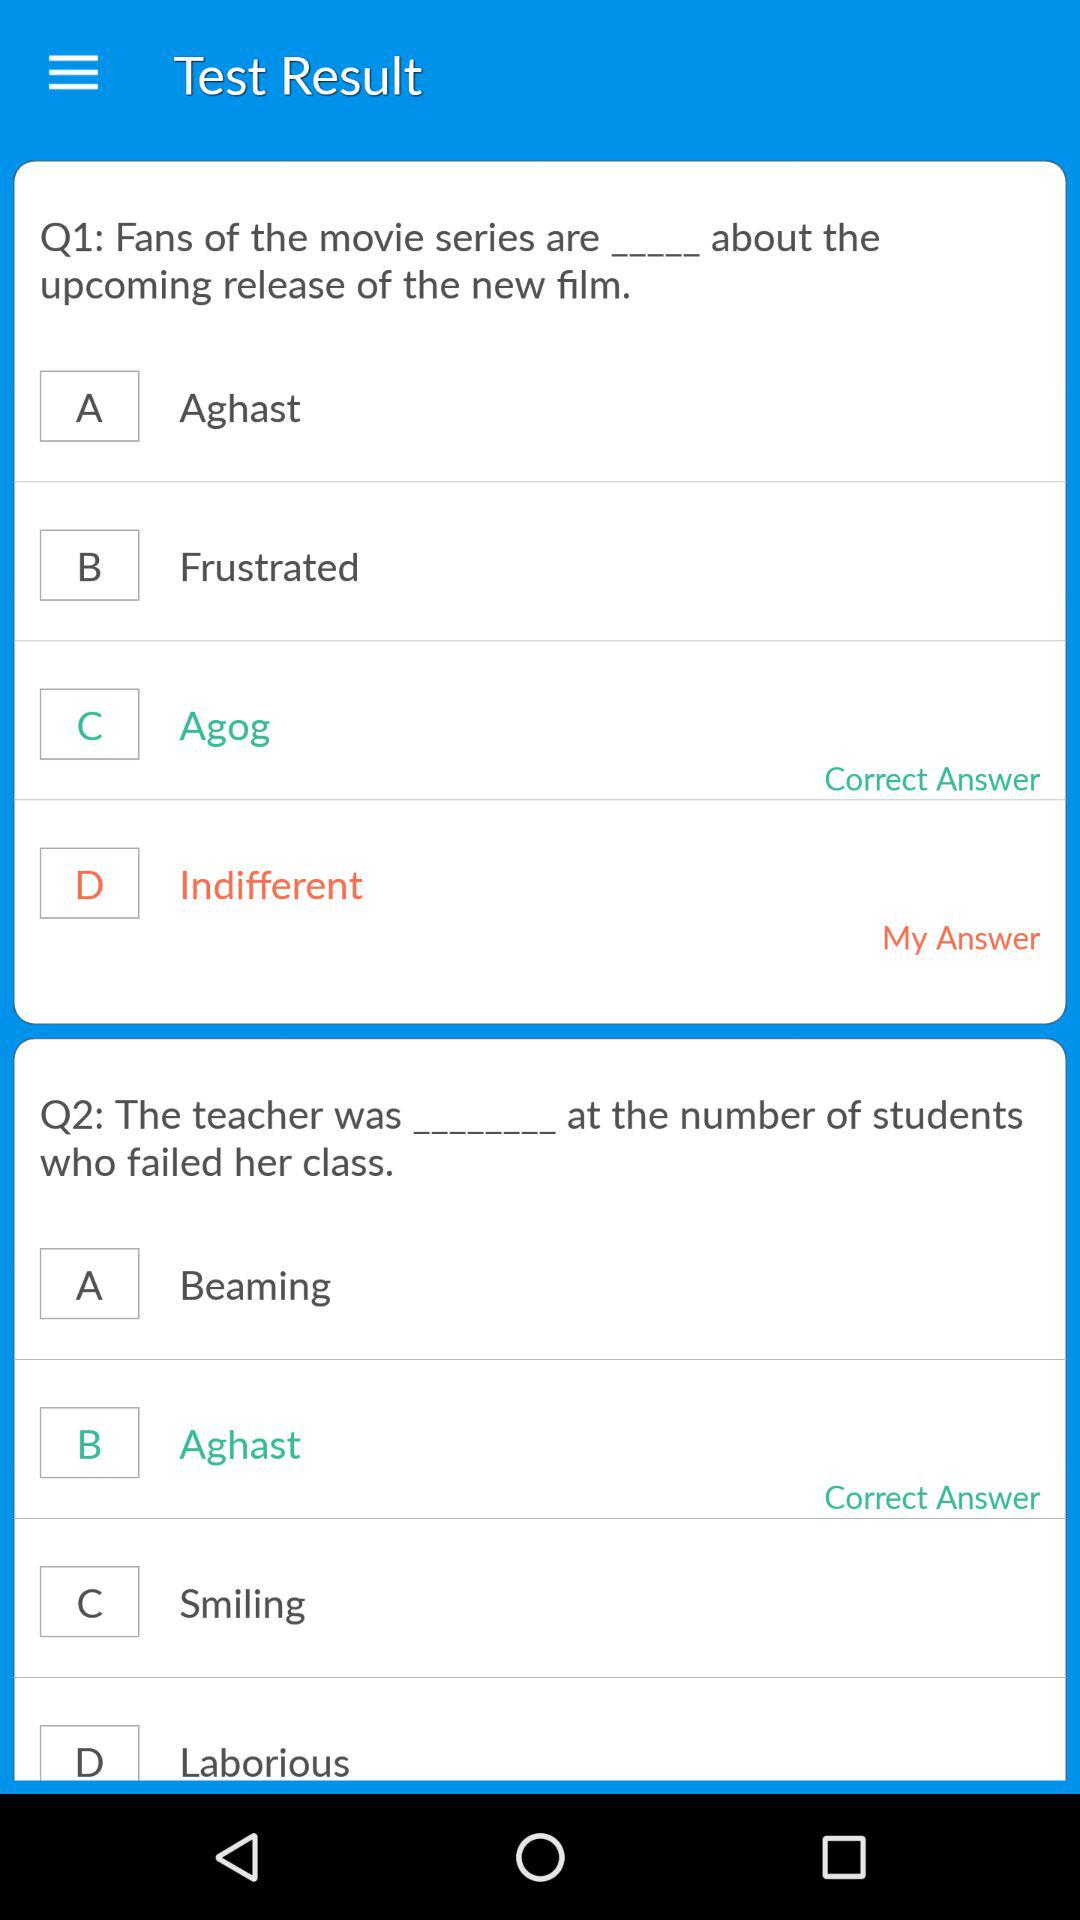What is the correct answer to the question about the fans of the upcoming release of the new film? The correct answer is "Agog". 